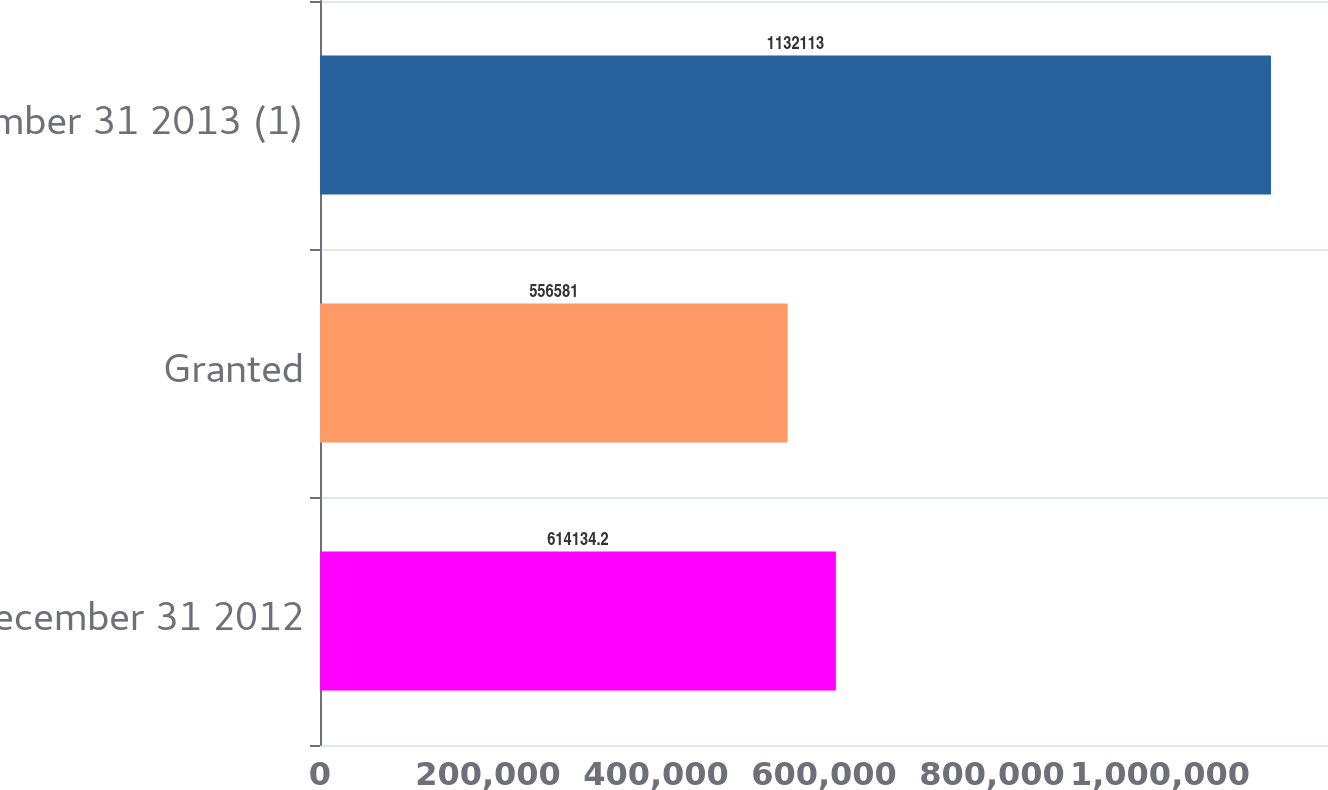Convert chart to OTSL. <chart><loc_0><loc_0><loc_500><loc_500><bar_chart><fcel>December 31 2012<fcel>Granted<fcel>December 31 2013 (1)<nl><fcel>614134<fcel>556581<fcel>1.13211e+06<nl></chart> 